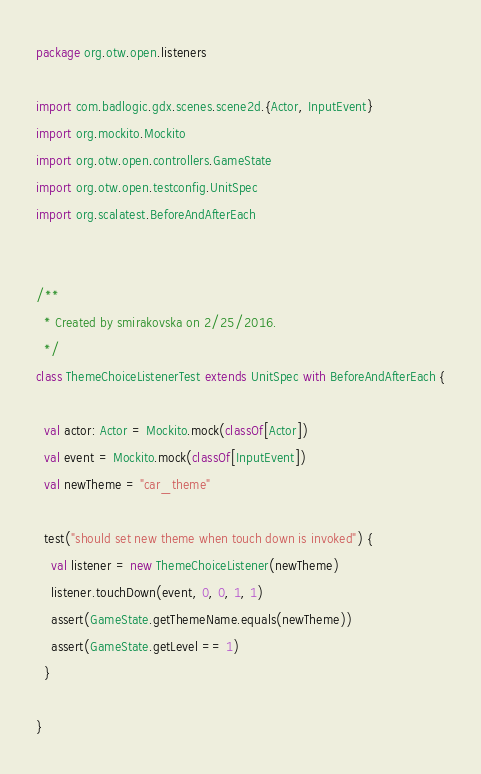Convert code to text. <code><loc_0><loc_0><loc_500><loc_500><_Scala_>package org.otw.open.listeners

import com.badlogic.gdx.scenes.scene2d.{Actor, InputEvent}
import org.mockito.Mockito
import org.otw.open.controllers.GameState
import org.otw.open.testconfig.UnitSpec
import org.scalatest.BeforeAndAfterEach


/**
  * Created by smirakovska on 2/25/2016.
  */
class ThemeChoiceListenerTest extends UnitSpec with BeforeAndAfterEach {

  val actor: Actor = Mockito.mock(classOf[Actor])
  val event = Mockito.mock(classOf[InputEvent])
  val newTheme = "car_theme"

  test("should set new theme when touch down is invoked") {
    val listener = new ThemeChoiceListener(newTheme)
    listener.touchDown(event, 0, 0, 1, 1)
    assert(GameState.getThemeName.equals(newTheme))
    assert(GameState.getLevel == 1)
  }

}
</code> 